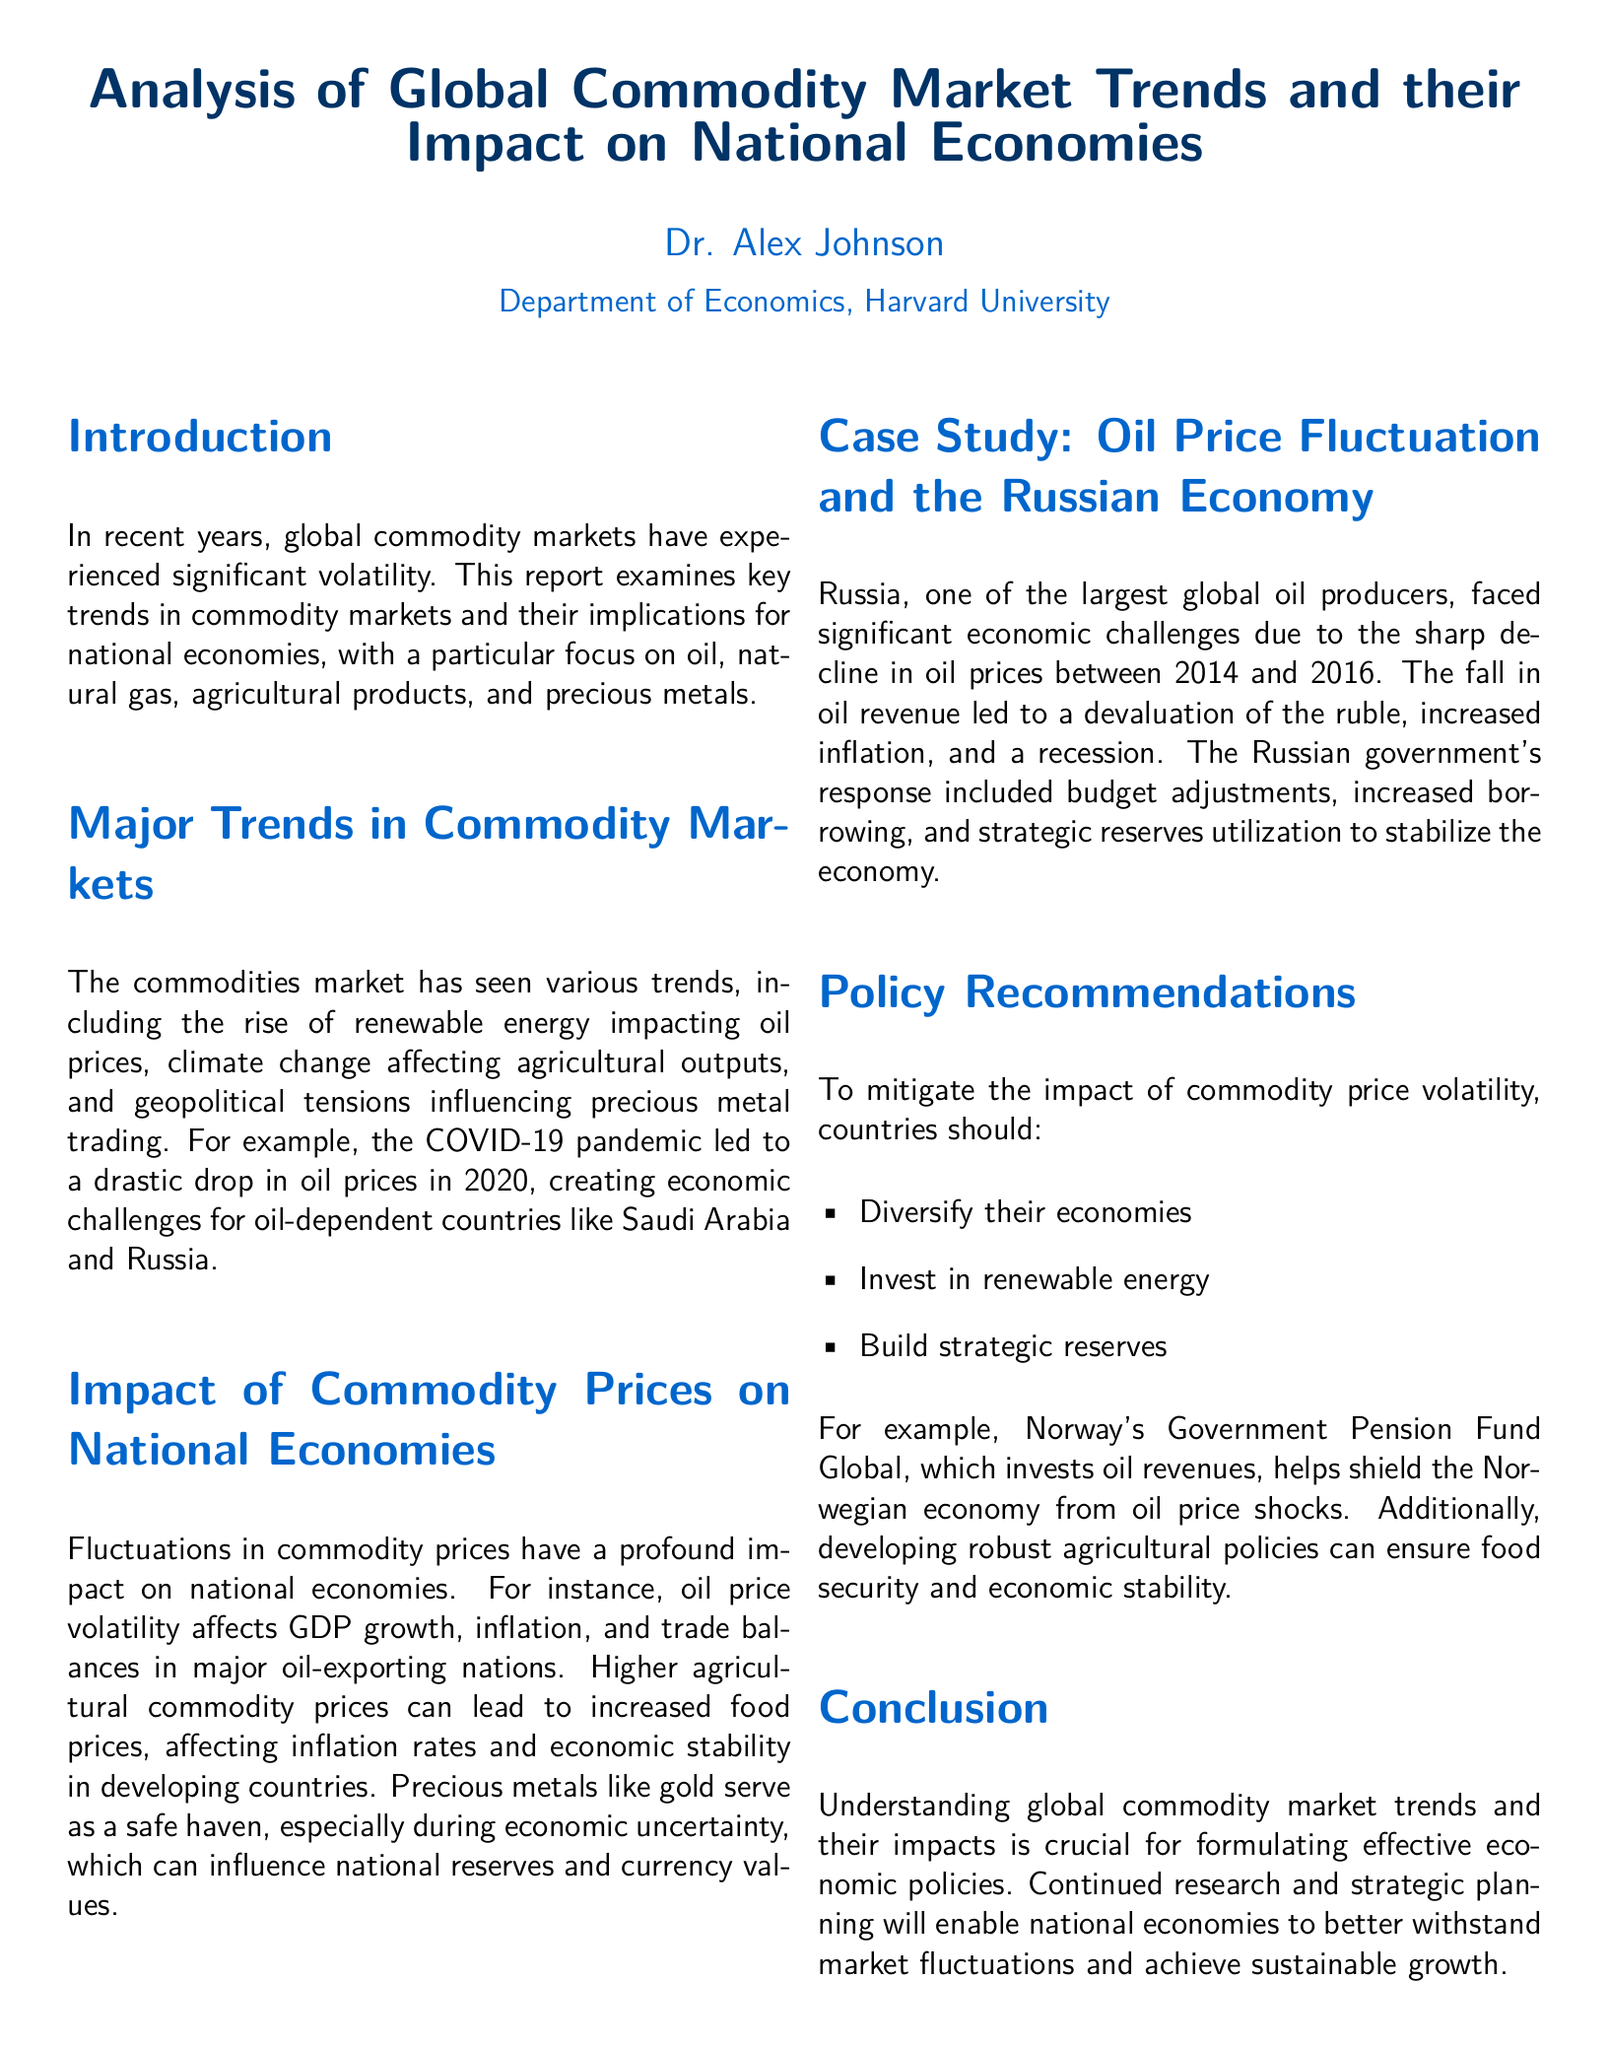what is the main topic of the document? The document focuses on trends in commodity markets and their effects on national economies.
Answer: Analysis of Global Commodity Market Trends and their Impact on National Economies who is the author of the document? The document lists Dr. Alex Johnson as the author.
Answer: Dr. Alex Johnson which commodities are emphasized in the analysis? The document emphasizes oil, natural gas, agricultural products, and precious metals.
Answer: oil, natural gas, agricultural products, and precious metals what significant event caused a drop in oil prices in 2020? The document states that COVID-19 pandemic led to a drastic drop in oil prices.
Answer: COVID-19 pandemic what is one of the policy recommendations provided? One of the recommendations is to invest in renewable energy to mitigate commodity price volatility.
Answer: invest in renewable energy how did the Russian government respond to economic challenges from oil price drops? The document mentions budget adjustments, increased borrowing, and strategic reserves utilization as responses.
Answer: budget adjustments, increased borrowing, and strategic reserves utilization what role do precious metals like gold play during economic uncertainty? The document describes precious metals as a safe haven during economic uncertainty.
Answer: safe haven which country is mentioned as having a Government Pension Fund Global? The document refers to Norway regarding its Government Pension Fund Global.
Answer: Norway 